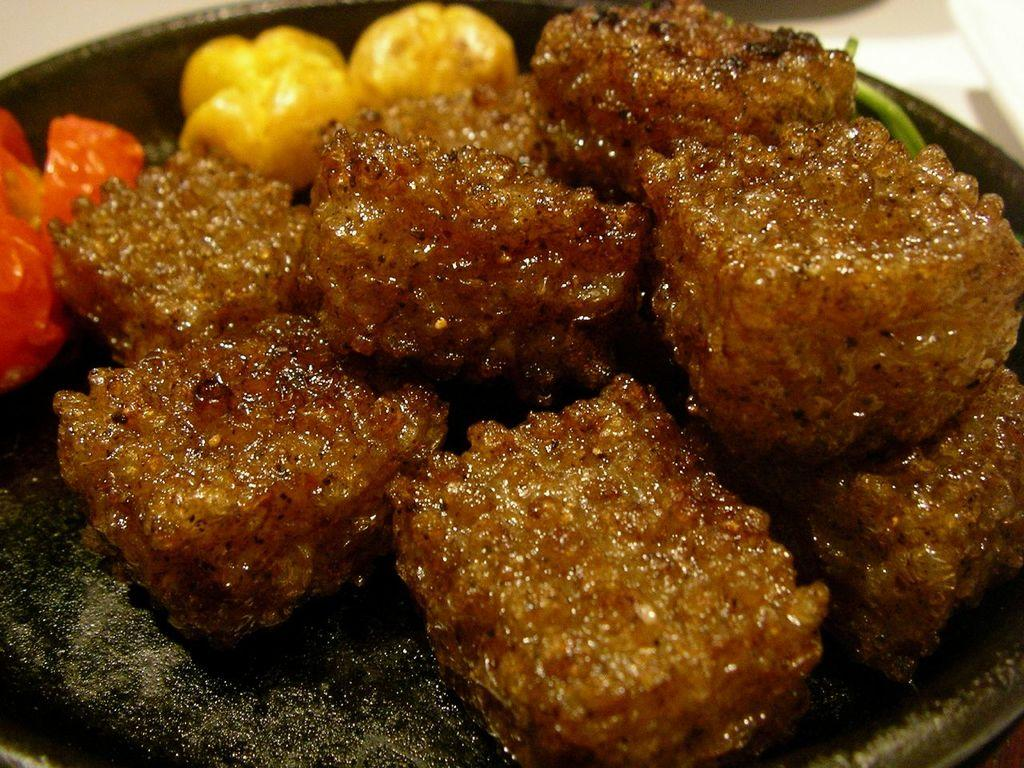What is located in the center of the image? There is a plate in the center of the image. What is on the plate? There is a food item on the plate. Where is the faucet located in the image? There is no faucet present in the image. Can you see any lakes or bodies of water in the image? There is no lake or body of water visible in the image. 